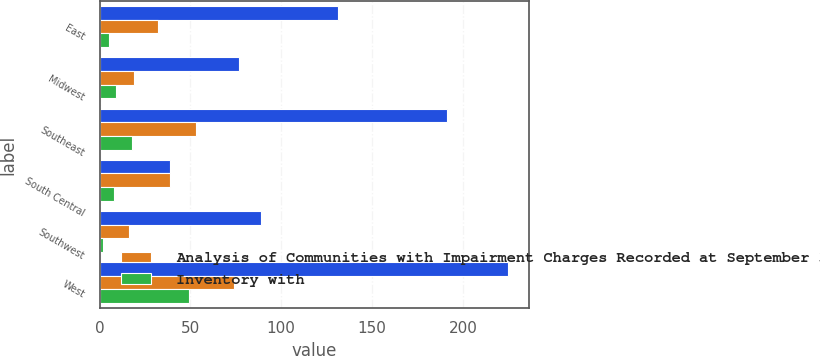<chart> <loc_0><loc_0><loc_500><loc_500><stacked_bar_chart><ecel><fcel>East<fcel>Midwest<fcel>Southeast<fcel>South Central<fcel>Southwest<fcel>West<nl><fcel>nan<fcel>131<fcel>77<fcel>191<fcel>39<fcel>89<fcel>225<nl><fcel>Analysis of Communities with Impairment Charges Recorded at September 30 2007<fcel>32<fcel>19<fcel>53<fcel>39<fcel>16<fcel>74<nl><fcel>Inventory with<fcel>5<fcel>9<fcel>18<fcel>8<fcel>2<fcel>49<nl></chart> 